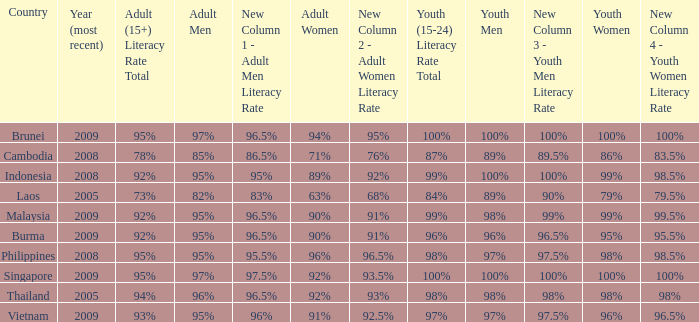Can you give me this table as a dict? {'header': ['Country', 'Year (most recent)', 'Adult (15+) Literacy Rate Total', 'Adult Men', 'New Column 1 - Adult Men Literacy Rate', 'Adult Women', 'New Column 2 - Adult Women Literacy Rate', 'Youth (15-24) Literacy Rate Total', 'Youth Men', 'New Column 3 - Youth Men Literacy Rate', 'Youth Women', 'New Column 4 - Youth Women Literacy Rate'], 'rows': [['Brunei', '2009', '95%', '97%', '96.5%', '94%', '95%', '100%', '100%', '100%', '100%', '100%'], ['Cambodia', '2008', '78%', '85%', '86.5%', '71%', '76%', '87%', '89%', '89.5%', '86%', '83.5%'], ['Indonesia', '2008', '92%', '95%', '95%', '89%', '92%', '99%', '100%', '100%', '99%', '98.5%'], ['Laos', '2005', '73%', '82%', '83%', '63%', '68%', '84%', '89%', '90%', '79%', '79.5%'], ['Malaysia', '2009', '92%', '95%', '96.5%', '90%', '91%', '99%', '98%', '99%', '99%', '99.5%'], ['Burma', '2009', '92%', '95%', '96.5%', '90%', '91%', '96%', '96%', '96.5%', '95%', '95.5%'], ['Philippines', '2008', '95%', '95%', '95.5%', '96%', '96.5%', '98%', '97%', '97.5%', '98%', '98.5%'], ['Singapore', '2009', '95%', '97%', '97.5%', '92%', '93.5%', '100%', '100%', '100%', '100%', '100%'], ['Thailand', '2005', '94%', '96%', '96.5%', '92%', '93%', '98%', '98%', '98%', '98%', '98%'], ['Vietnam', '2009', '93%', '95%', '96%', '91%', '92.5%', '97%', '97%', '97.5%', '96%', '96.5%']]} What country has a Youth (15-24) Literacy Rate Total of 99%, and a Youth Men of 98%? Malaysia. 